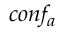<formula> <loc_0><loc_0><loc_500><loc_500>c o n f _ { a }</formula> 